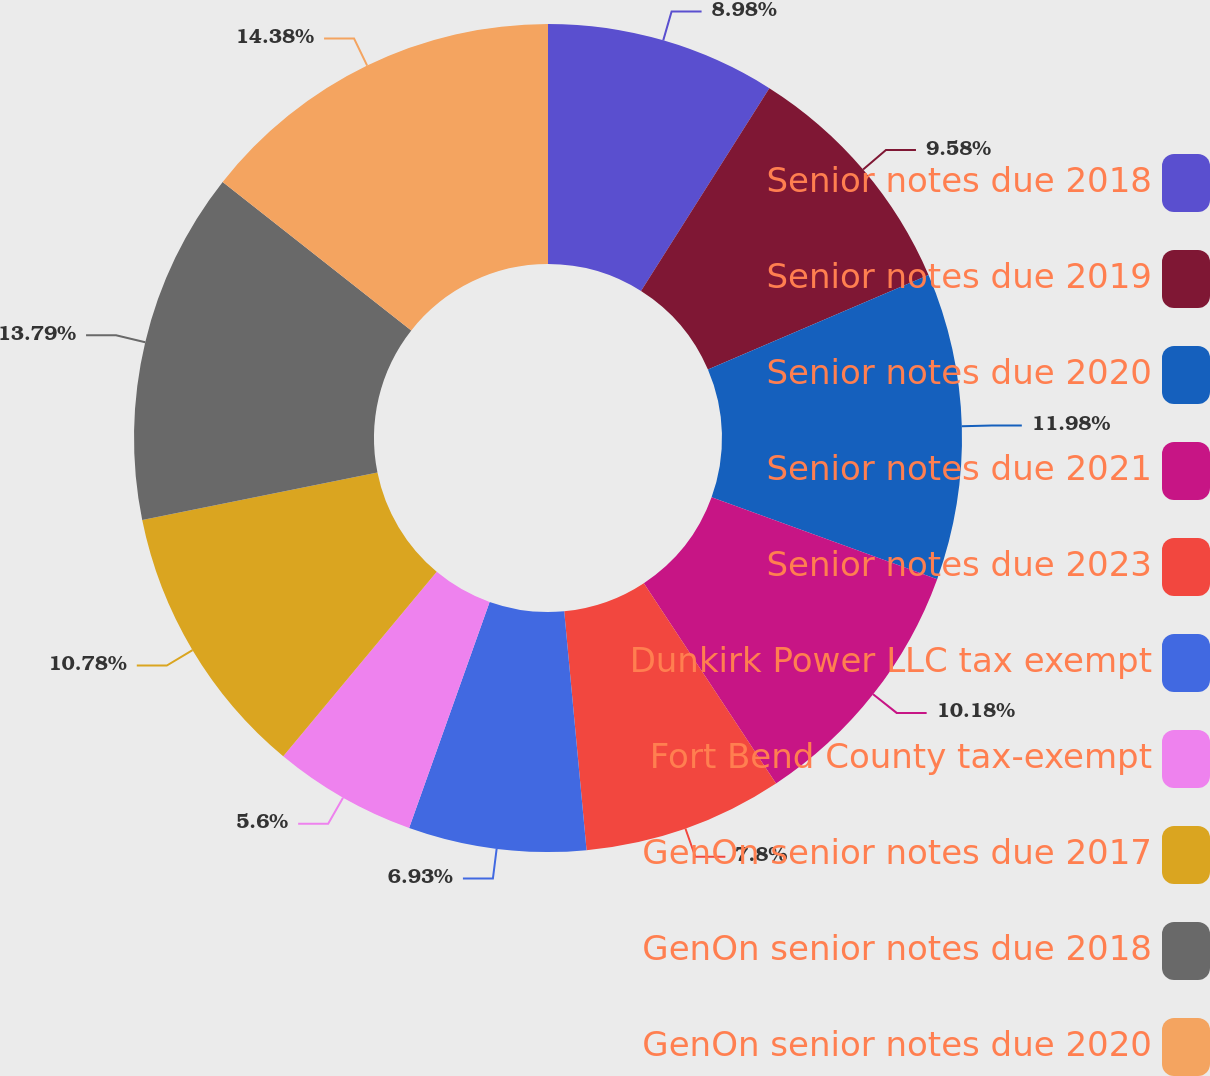Convert chart. <chart><loc_0><loc_0><loc_500><loc_500><pie_chart><fcel>Senior notes due 2018<fcel>Senior notes due 2019<fcel>Senior notes due 2020<fcel>Senior notes due 2021<fcel>Senior notes due 2023<fcel>Dunkirk Power LLC tax exempt<fcel>Fort Bend County tax-exempt<fcel>GenOn senior notes due 2017<fcel>GenOn senior notes due 2018<fcel>GenOn senior notes due 2020<nl><fcel>8.98%<fcel>9.58%<fcel>11.98%<fcel>10.18%<fcel>7.8%<fcel>6.93%<fcel>5.6%<fcel>10.78%<fcel>13.79%<fcel>14.39%<nl></chart> 